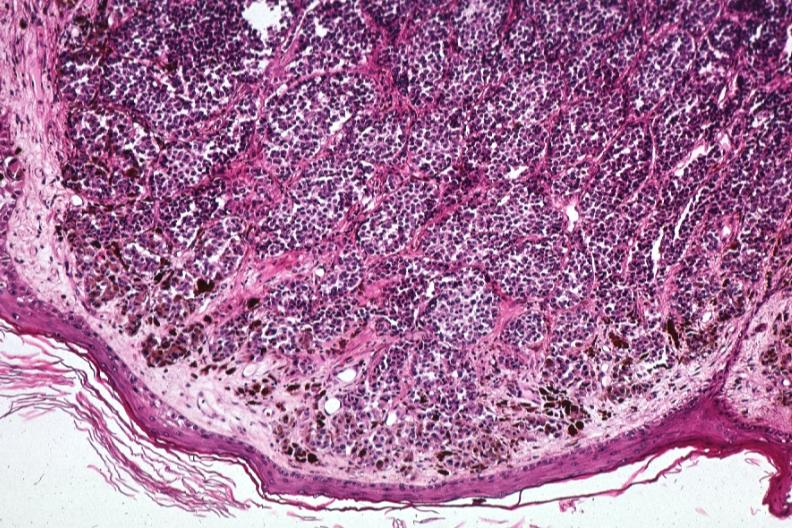how are low excellent depiction of lesion that probably is metastatic slides 1 lesion?
Answer the question using a single word or phrase. Same 